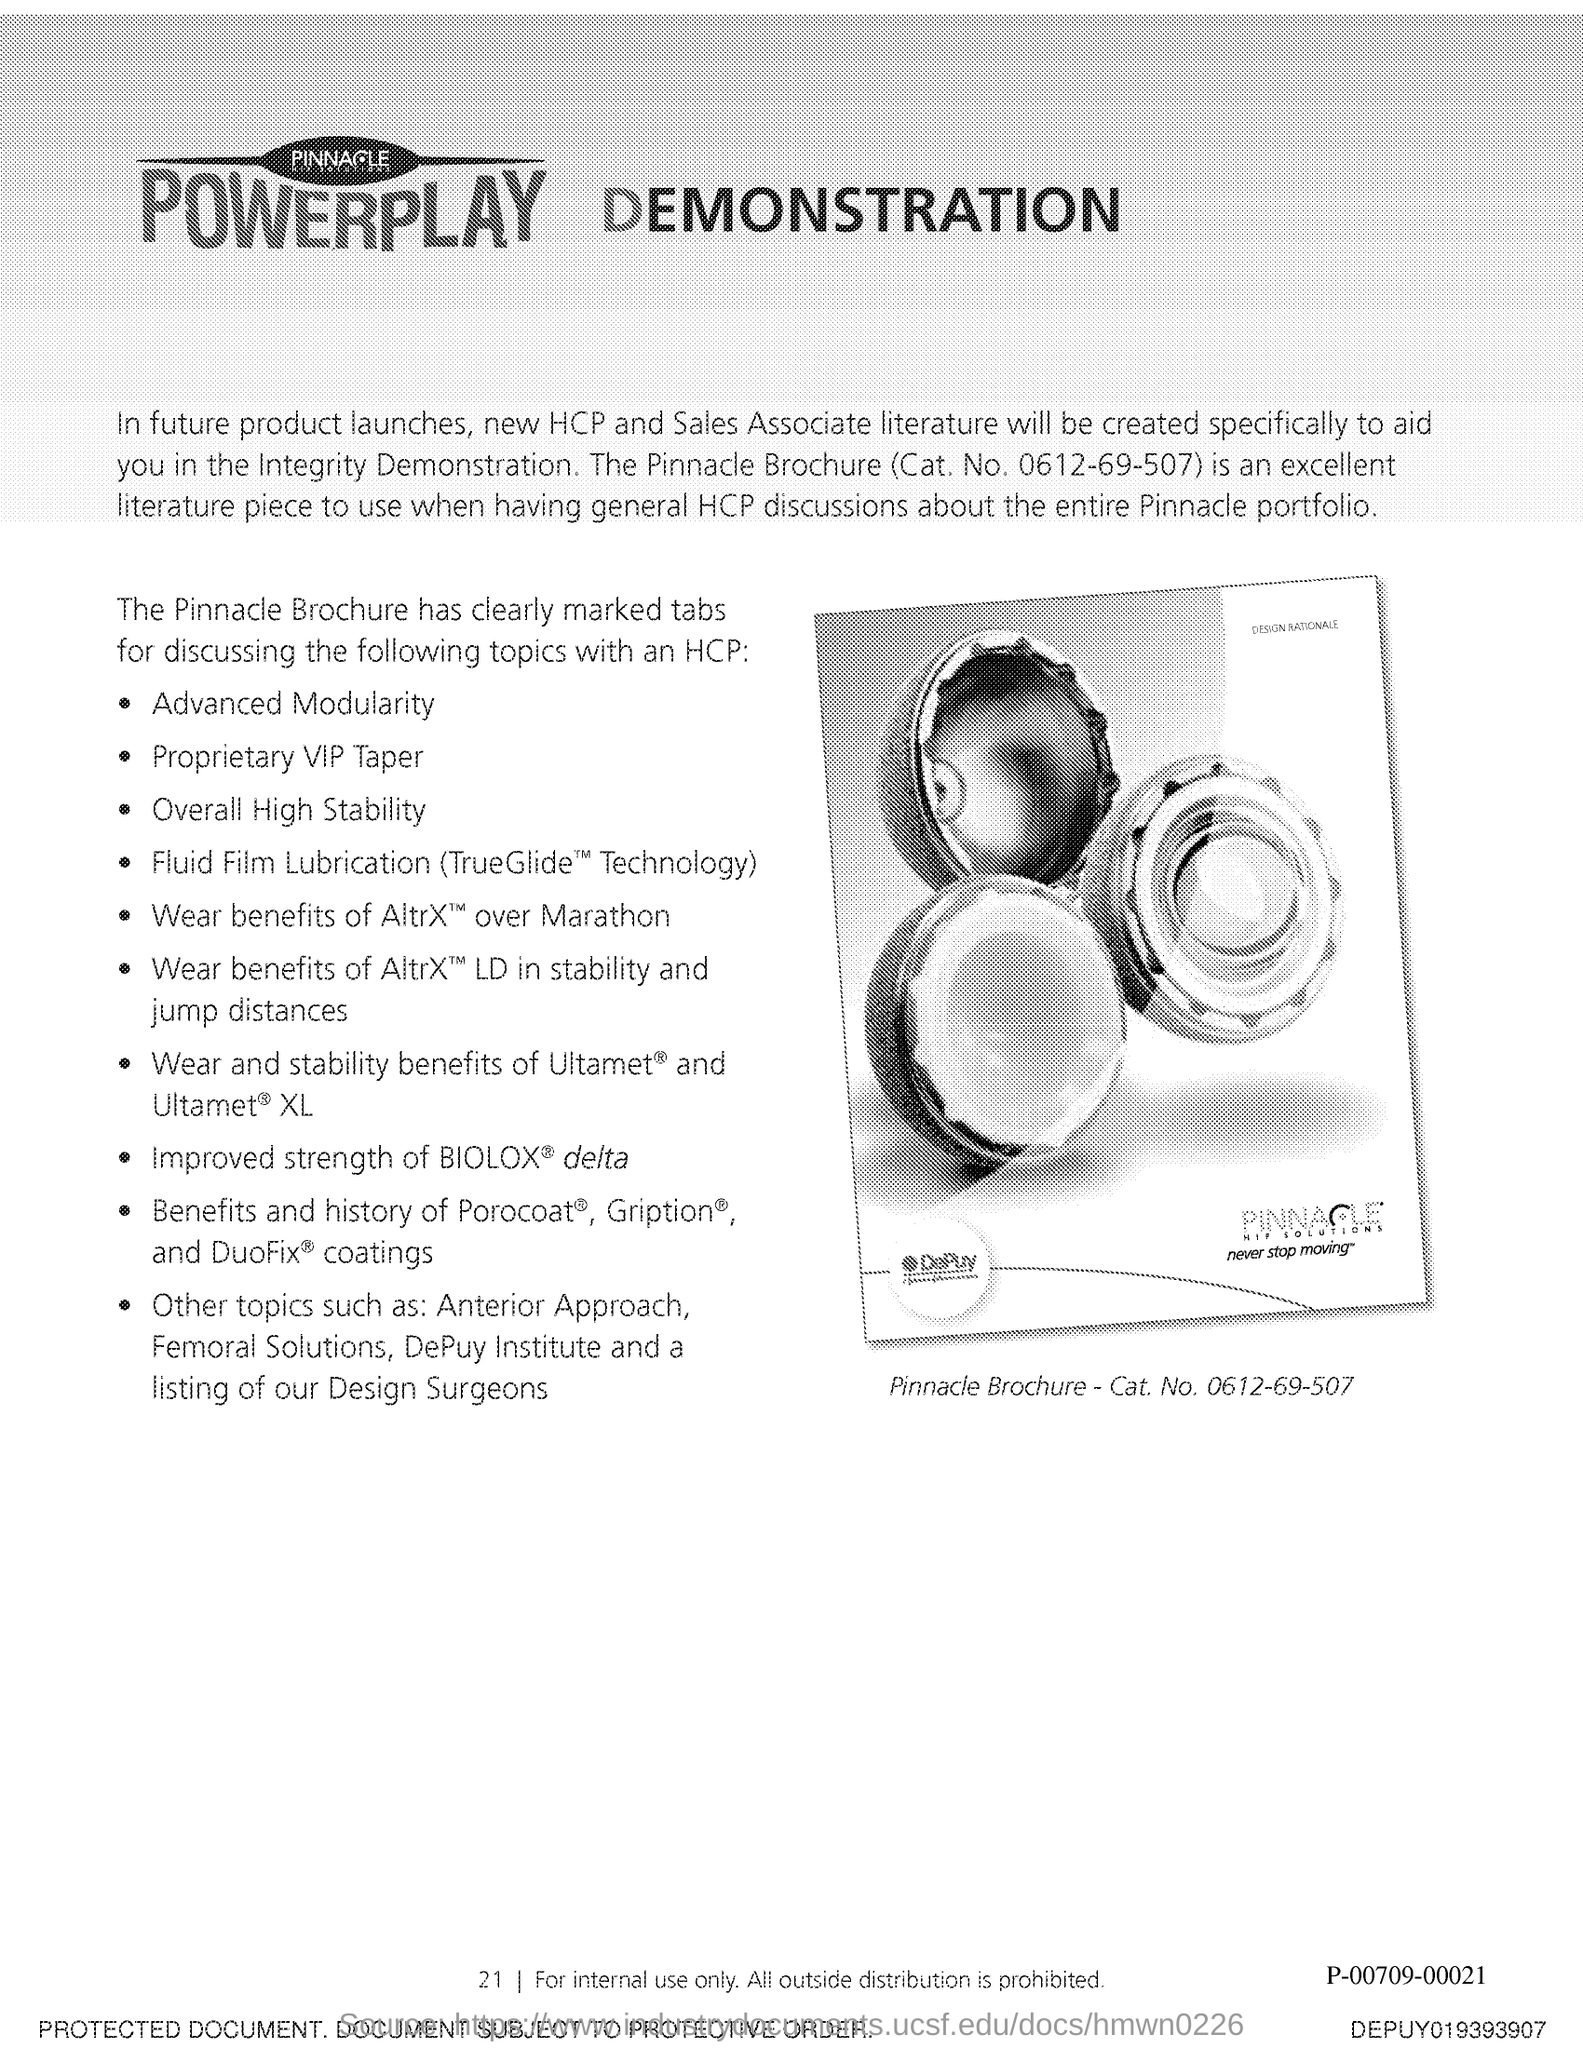What is the Pinnacle Brochure Cat. No.?
Give a very brief answer. 0612-69-507. What is an excellent literature piece to use when having general HCP discussions about entir Pinnacle Portfolio?
Keep it short and to the point. The Pinnacle Brochure. 